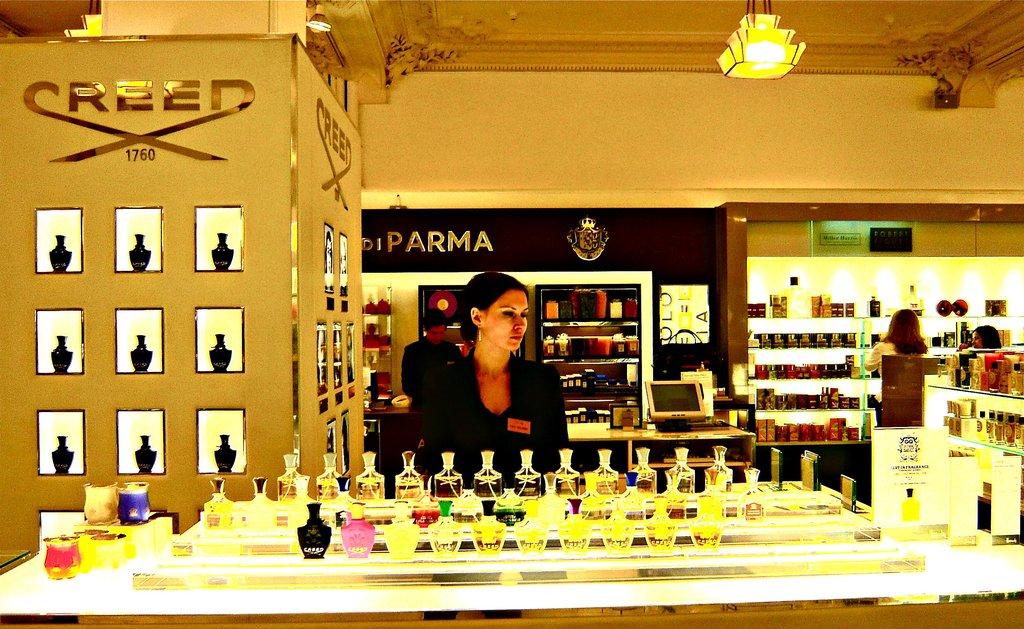What is the name of the brand the lady is selling?
Provide a short and direct response. Creed. What brand name is behind the salesperson?
Your response must be concise. Parma. 